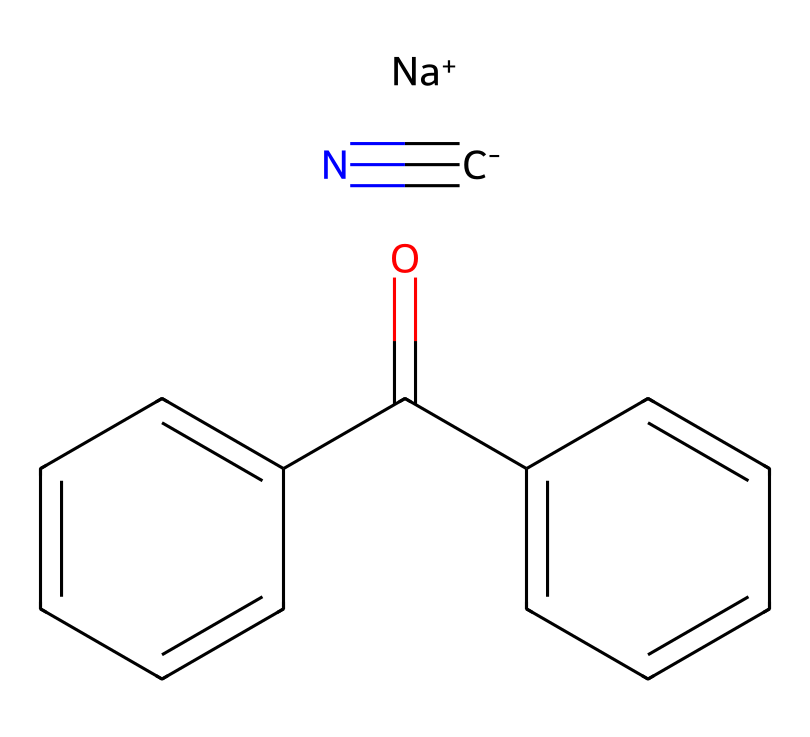what is the main cation in this ionic liquid? The ionic liquid is composed of sodium cation as indicated by the presence of [Na+] in the SMILES representation.
Answer: sodium how many carbon atoms are present in the structure? In the SMILES, the structural components include four aromatic carbons from two benzene rings and an additional five carbon atoms from the side chains, totaling nine carbon atoms in the entire structure.
Answer: nine what type of ionic interaction is predominant in this ionic liquid? The ionic interaction in this ionic liquid is predominantly based on electrostatic interactions between the sodium cation ([Na+]) and the anionic components (represented by the cyanide and aromatic groups), typical of ionic liquids.
Answer: electrostatic how many double bonds are found in the compound? The compound contains four double bonds: two in the benzene rings and two in the group connecting the aromatic compounds, hence the total is four.
Answer: four what functional group is present at the end of the side chain? The side chain at the end contains a carbonyl functional group (C=O), which is suggested by the presence of C(=O) in the SMILES.
Answer: carbonyl why does this ionic liquid exhibit luminescent properties? The luminescent properties stem mainly from the presence of the conjugated system in the aromatic rings and the fact that they can engage in π-π interactions, which allows for electronic excitations resulting in luminescence.
Answer: conjugated system what is the anion associated with this ionic liquid? The anion can be inferred from the components before the sodium, which includes an aromatic structure and a cyanide group. The presence of a specific anion can be suggested as a complex anion derived from these elements.
Answer: complex anion 